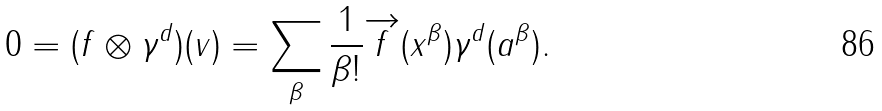<formula> <loc_0><loc_0><loc_500><loc_500>0 = ( f \otimes \gamma ^ { d } ) ( v ) = \sum _ { \beta } \frac { 1 } { \beta ! } \overrightarrow { f } ( x ^ { \beta } ) \gamma ^ { d } ( a ^ { \beta } ) .</formula> 